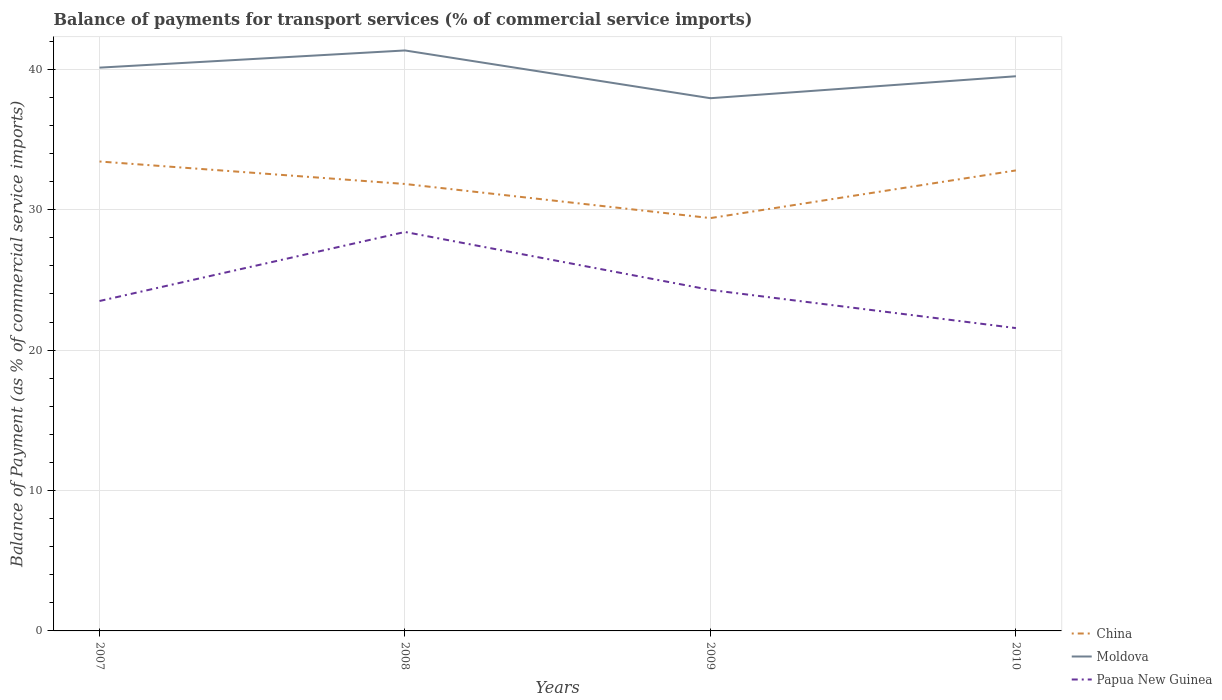Does the line corresponding to Moldova intersect with the line corresponding to Papua New Guinea?
Your answer should be very brief. No. Across all years, what is the maximum balance of payments for transport services in Moldova?
Keep it short and to the point. 37.94. What is the total balance of payments for transport services in Papua New Guinea in the graph?
Give a very brief answer. 6.85. What is the difference between the highest and the second highest balance of payments for transport services in Papua New Guinea?
Your answer should be compact. 6.85. Is the balance of payments for transport services in Moldova strictly greater than the balance of payments for transport services in China over the years?
Make the answer very short. No. How many lines are there?
Give a very brief answer. 3. How many years are there in the graph?
Ensure brevity in your answer.  4. Are the values on the major ticks of Y-axis written in scientific E-notation?
Your answer should be very brief. No. Does the graph contain any zero values?
Provide a short and direct response. No. Does the graph contain grids?
Offer a terse response. Yes. How are the legend labels stacked?
Your answer should be very brief. Vertical. What is the title of the graph?
Make the answer very short. Balance of payments for transport services (% of commercial service imports). Does "High income: OECD" appear as one of the legend labels in the graph?
Offer a terse response. No. What is the label or title of the X-axis?
Provide a succinct answer. Years. What is the label or title of the Y-axis?
Your response must be concise. Balance of Payment (as % of commercial service imports). What is the Balance of Payment (as % of commercial service imports) of China in 2007?
Ensure brevity in your answer.  33.44. What is the Balance of Payment (as % of commercial service imports) in Moldova in 2007?
Ensure brevity in your answer.  40.12. What is the Balance of Payment (as % of commercial service imports) in Papua New Guinea in 2007?
Provide a succinct answer. 23.5. What is the Balance of Payment (as % of commercial service imports) in China in 2008?
Your answer should be compact. 31.83. What is the Balance of Payment (as % of commercial service imports) of Moldova in 2008?
Make the answer very short. 41.34. What is the Balance of Payment (as % of commercial service imports) in Papua New Guinea in 2008?
Give a very brief answer. 28.42. What is the Balance of Payment (as % of commercial service imports) of China in 2009?
Offer a very short reply. 29.4. What is the Balance of Payment (as % of commercial service imports) in Moldova in 2009?
Provide a succinct answer. 37.94. What is the Balance of Payment (as % of commercial service imports) in Papua New Guinea in 2009?
Offer a terse response. 24.29. What is the Balance of Payment (as % of commercial service imports) of China in 2010?
Your response must be concise. 32.8. What is the Balance of Payment (as % of commercial service imports) in Moldova in 2010?
Ensure brevity in your answer.  39.51. What is the Balance of Payment (as % of commercial service imports) of Papua New Guinea in 2010?
Your answer should be very brief. 21.57. Across all years, what is the maximum Balance of Payment (as % of commercial service imports) of China?
Provide a succinct answer. 33.44. Across all years, what is the maximum Balance of Payment (as % of commercial service imports) in Moldova?
Ensure brevity in your answer.  41.34. Across all years, what is the maximum Balance of Payment (as % of commercial service imports) in Papua New Guinea?
Your answer should be very brief. 28.42. Across all years, what is the minimum Balance of Payment (as % of commercial service imports) in China?
Offer a very short reply. 29.4. Across all years, what is the minimum Balance of Payment (as % of commercial service imports) of Moldova?
Keep it short and to the point. 37.94. Across all years, what is the minimum Balance of Payment (as % of commercial service imports) of Papua New Guinea?
Give a very brief answer. 21.57. What is the total Balance of Payment (as % of commercial service imports) in China in the graph?
Your answer should be compact. 127.47. What is the total Balance of Payment (as % of commercial service imports) of Moldova in the graph?
Give a very brief answer. 158.91. What is the total Balance of Payment (as % of commercial service imports) in Papua New Guinea in the graph?
Provide a short and direct response. 97.77. What is the difference between the Balance of Payment (as % of commercial service imports) of China in 2007 and that in 2008?
Ensure brevity in your answer.  1.6. What is the difference between the Balance of Payment (as % of commercial service imports) of Moldova in 2007 and that in 2008?
Provide a succinct answer. -1.22. What is the difference between the Balance of Payment (as % of commercial service imports) of Papua New Guinea in 2007 and that in 2008?
Make the answer very short. -4.92. What is the difference between the Balance of Payment (as % of commercial service imports) in China in 2007 and that in 2009?
Your answer should be very brief. 4.03. What is the difference between the Balance of Payment (as % of commercial service imports) in Moldova in 2007 and that in 2009?
Provide a short and direct response. 2.18. What is the difference between the Balance of Payment (as % of commercial service imports) in Papua New Guinea in 2007 and that in 2009?
Provide a short and direct response. -0.79. What is the difference between the Balance of Payment (as % of commercial service imports) of China in 2007 and that in 2010?
Your answer should be very brief. 0.64. What is the difference between the Balance of Payment (as % of commercial service imports) of Moldova in 2007 and that in 2010?
Your answer should be compact. 0.61. What is the difference between the Balance of Payment (as % of commercial service imports) of Papua New Guinea in 2007 and that in 2010?
Give a very brief answer. 1.93. What is the difference between the Balance of Payment (as % of commercial service imports) of China in 2008 and that in 2009?
Your answer should be very brief. 2.43. What is the difference between the Balance of Payment (as % of commercial service imports) of Moldova in 2008 and that in 2009?
Make the answer very short. 3.4. What is the difference between the Balance of Payment (as % of commercial service imports) of Papua New Guinea in 2008 and that in 2009?
Make the answer very short. 4.13. What is the difference between the Balance of Payment (as % of commercial service imports) in China in 2008 and that in 2010?
Offer a terse response. -0.97. What is the difference between the Balance of Payment (as % of commercial service imports) in Moldova in 2008 and that in 2010?
Keep it short and to the point. 1.84. What is the difference between the Balance of Payment (as % of commercial service imports) of Papua New Guinea in 2008 and that in 2010?
Keep it short and to the point. 6.85. What is the difference between the Balance of Payment (as % of commercial service imports) of China in 2009 and that in 2010?
Give a very brief answer. -3.4. What is the difference between the Balance of Payment (as % of commercial service imports) of Moldova in 2009 and that in 2010?
Offer a very short reply. -1.56. What is the difference between the Balance of Payment (as % of commercial service imports) in Papua New Guinea in 2009 and that in 2010?
Offer a very short reply. 2.72. What is the difference between the Balance of Payment (as % of commercial service imports) in China in 2007 and the Balance of Payment (as % of commercial service imports) in Moldova in 2008?
Ensure brevity in your answer.  -7.91. What is the difference between the Balance of Payment (as % of commercial service imports) of China in 2007 and the Balance of Payment (as % of commercial service imports) of Papua New Guinea in 2008?
Your response must be concise. 5.02. What is the difference between the Balance of Payment (as % of commercial service imports) in Moldova in 2007 and the Balance of Payment (as % of commercial service imports) in Papua New Guinea in 2008?
Make the answer very short. 11.7. What is the difference between the Balance of Payment (as % of commercial service imports) in China in 2007 and the Balance of Payment (as % of commercial service imports) in Moldova in 2009?
Offer a terse response. -4.51. What is the difference between the Balance of Payment (as % of commercial service imports) of China in 2007 and the Balance of Payment (as % of commercial service imports) of Papua New Guinea in 2009?
Your response must be concise. 9.15. What is the difference between the Balance of Payment (as % of commercial service imports) of Moldova in 2007 and the Balance of Payment (as % of commercial service imports) of Papua New Guinea in 2009?
Your answer should be compact. 15.83. What is the difference between the Balance of Payment (as % of commercial service imports) of China in 2007 and the Balance of Payment (as % of commercial service imports) of Moldova in 2010?
Make the answer very short. -6.07. What is the difference between the Balance of Payment (as % of commercial service imports) of China in 2007 and the Balance of Payment (as % of commercial service imports) of Papua New Guinea in 2010?
Provide a short and direct response. 11.87. What is the difference between the Balance of Payment (as % of commercial service imports) in Moldova in 2007 and the Balance of Payment (as % of commercial service imports) in Papua New Guinea in 2010?
Give a very brief answer. 18.55. What is the difference between the Balance of Payment (as % of commercial service imports) of China in 2008 and the Balance of Payment (as % of commercial service imports) of Moldova in 2009?
Make the answer very short. -6.11. What is the difference between the Balance of Payment (as % of commercial service imports) in China in 2008 and the Balance of Payment (as % of commercial service imports) in Papua New Guinea in 2009?
Provide a succinct answer. 7.55. What is the difference between the Balance of Payment (as % of commercial service imports) in Moldova in 2008 and the Balance of Payment (as % of commercial service imports) in Papua New Guinea in 2009?
Keep it short and to the point. 17.06. What is the difference between the Balance of Payment (as % of commercial service imports) of China in 2008 and the Balance of Payment (as % of commercial service imports) of Moldova in 2010?
Keep it short and to the point. -7.67. What is the difference between the Balance of Payment (as % of commercial service imports) in China in 2008 and the Balance of Payment (as % of commercial service imports) in Papua New Guinea in 2010?
Provide a succinct answer. 10.26. What is the difference between the Balance of Payment (as % of commercial service imports) in Moldova in 2008 and the Balance of Payment (as % of commercial service imports) in Papua New Guinea in 2010?
Offer a terse response. 19.77. What is the difference between the Balance of Payment (as % of commercial service imports) of China in 2009 and the Balance of Payment (as % of commercial service imports) of Moldova in 2010?
Offer a very short reply. -10.1. What is the difference between the Balance of Payment (as % of commercial service imports) in China in 2009 and the Balance of Payment (as % of commercial service imports) in Papua New Guinea in 2010?
Your answer should be very brief. 7.83. What is the difference between the Balance of Payment (as % of commercial service imports) in Moldova in 2009 and the Balance of Payment (as % of commercial service imports) in Papua New Guinea in 2010?
Make the answer very short. 16.37. What is the average Balance of Payment (as % of commercial service imports) in China per year?
Ensure brevity in your answer.  31.87. What is the average Balance of Payment (as % of commercial service imports) in Moldova per year?
Offer a very short reply. 39.73. What is the average Balance of Payment (as % of commercial service imports) in Papua New Guinea per year?
Offer a very short reply. 24.44. In the year 2007, what is the difference between the Balance of Payment (as % of commercial service imports) of China and Balance of Payment (as % of commercial service imports) of Moldova?
Offer a very short reply. -6.68. In the year 2007, what is the difference between the Balance of Payment (as % of commercial service imports) of China and Balance of Payment (as % of commercial service imports) of Papua New Guinea?
Make the answer very short. 9.94. In the year 2007, what is the difference between the Balance of Payment (as % of commercial service imports) of Moldova and Balance of Payment (as % of commercial service imports) of Papua New Guinea?
Provide a succinct answer. 16.62. In the year 2008, what is the difference between the Balance of Payment (as % of commercial service imports) of China and Balance of Payment (as % of commercial service imports) of Moldova?
Keep it short and to the point. -9.51. In the year 2008, what is the difference between the Balance of Payment (as % of commercial service imports) of China and Balance of Payment (as % of commercial service imports) of Papua New Guinea?
Offer a very short reply. 3.42. In the year 2008, what is the difference between the Balance of Payment (as % of commercial service imports) in Moldova and Balance of Payment (as % of commercial service imports) in Papua New Guinea?
Make the answer very short. 12.93. In the year 2009, what is the difference between the Balance of Payment (as % of commercial service imports) in China and Balance of Payment (as % of commercial service imports) in Moldova?
Make the answer very short. -8.54. In the year 2009, what is the difference between the Balance of Payment (as % of commercial service imports) in China and Balance of Payment (as % of commercial service imports) in Papua New Guinea?
Make the answer very short. 5.12. In the year 2009, what is the difference between the Balance of Payment (as % of commercial service imports) in Moldova and Balance of Payment (as % of commercial service imports) in Papua New Guinea?
Provide a succinct answer. 13.66. In the year 2010, what is the difference between the Balance of Payment (as % of commercial service imports) of China and Balance of Payment (as % of commercial service imports) of Moldova?
Your response must be concise. -6.71. In the year 2010, what is the difference between the Balance of Payment (as % of commercial service imports) in China and Balance of Payment (as % of commercial service imports) in Papua New Guinea?
Provide a short and direct response. 11.23. In the year 2010, what is the difference between the Balance of Payment (as % of commercial service imports) in Moldova and Balance of Payment (as % of commercial service imports) in Papua New Guinea?
Ensure brevity in your answer.  17.94. What is the ratio of the Balance of Payment (as % of commercial service imports) of China in 2007 to that in 2008?
Offer a terse response. 1.05. What is the ratio of the Balance of Payment (as % of commercial service imports) in Moldova in 2007 to that in 2008?
Your answer should be compact. 0.97. What is the ratio of the Balance of Payment (as % of commercial service imports) of Papua New Guinea in 2007 to that in 2008?
Offer a terse response. 0.83. What is the ratio of the Balance of Payment (as % of commercial service imports) of China in 2007 to that in 2009?
Make the answer very short. 1.14. What is the ratio of the Balance of Payment (as % of commercial service imports) of Moldova in 2007 to that in 2009?
Your answer should be compact. 1.06. What is the ratio of the Balance of Payment (as % of commercial service imports) of Papua New Guinea in 2007 to that in 2009?
Your answer should be very brief. 0.97. What is the ratio of the Balance of Payment (as % of commercial service imports) of China in 2007 to that in 2010?
Keep it short and to the point. 1.02. What is the ratio of the Balance of Payment (as % of commercial service imports) of Moldova in 2007 to that in 2010?
Your response must be concise. 1.02. What is the ratio of the Balance of Payment (as % of commercial service imports) of Papua New Guinea in 2007 to that in 2010?
Offer a terse response. 1.09. What is the ratio of the Balance of Payment (as % of commercial service imports) in China in 2008 to that in 2009?
Provide a short and direct response. 1.08. What is the ratio of the Balance of Payment (as % of commercial service imports) in Moldova in 2008 to that in 2009?
Give a very brief answer. 1.09. What is the ratio of the Balance of Payment (as % of commercial service imports) in Papua New Guinea in 2008 to that in 2009?
Keep it short and to the point. 1.17. What is the ratio of the Balance of Payment (as % of commercial service imports) of China in 2008 to that in 2010?
Provide a succinct answer. 0.97. What is the ratio of the Balance of Payment (as % of commercial service imports) of Moldova in 2008 to that in 2010?
Offer a very short reply. 1.05. What is the ratio of the Balance of Payment (as % of commercial service imports) in Papua New Guinea in 2008 to that in 2010?
Make the answer very short. 1.32. What is the ratio of the Balance of Payment (as % of commercial service imports) in China in 2009 to that in 2010?
Provide a short and direct response. 0.9. What is the ratio of the Balance of Payment (as % of commercial service imports) of Moldova in 2009 to that in 2010?
Your answer should be very brief. 0.96. What is the ratio of the Balance of Payment (as % of commercial service imports) in Papua New Guinea in 2009 to that in 2010?
Offer a very short reply. 1.13. What is the difference between the highest and the second highest Balance of Payment (as % of commercial service imports) of China?
Provide a short and direct response. 0.64. What is the difference between the highest and the second highest Balance of Payment (as % of commercial service imports) in Moldova?
Your answer should be compact. 1.22. What is the difference between the highest and the second highest Balance of Payment (as % of commercial service imports) in Papua New Guinea?
Provide a succinct answer. 4.13. What is the difference between the highest and the lowest Balance of Payment (as % of commercial service imports) in China?
Provide a succinct answer. 4.03. What is the difference between the highest and the lowest Balance of Payment (as % of commercial service imports) of Moldova?
Ensure brevity in your answer.  3.4. What is the difference between the highest and the lowest Balance of Payment (as % of commercial service imports) of Papua New Guinea?
Your answer should be very brief. 6.85. 